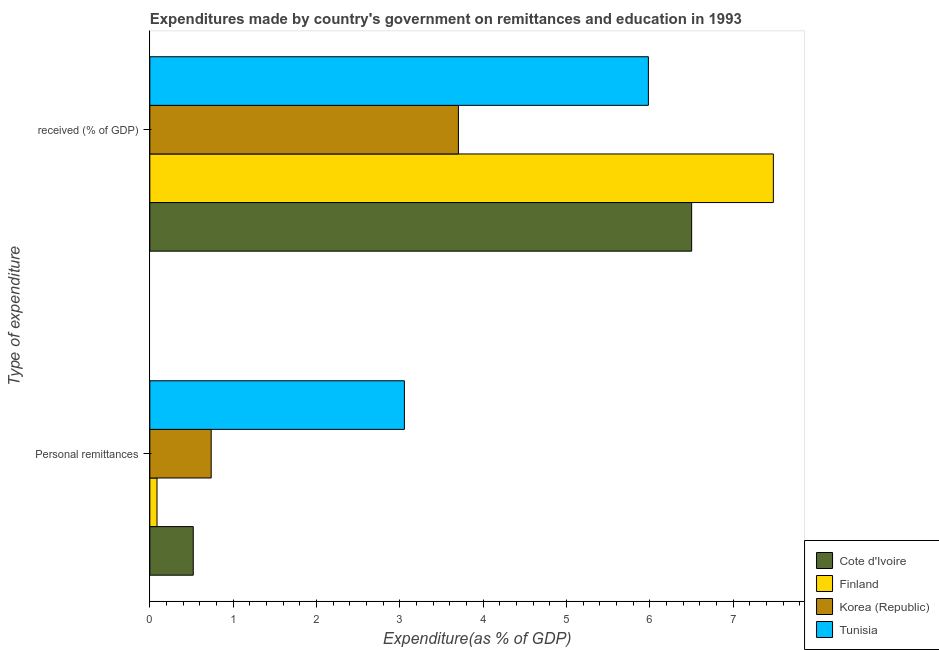How many different coloured bars are there?
Offer a terse response. 4. Are the number of bars per tick equal to the number of legend labels?
Ensure brevity in your answer.  Yes. Are the number of bars on each tick of the Y-axis equal?
Offer a very short reply. Yes. What is the label of the 2nd group of bars from the top?
Offer a terse response. Personal remittances. What is the expenditure in personal remittances in Tunisia?
Your answer should be compact. 3.06. Across all countries, what is the maximum expenditure in education?
Offer a terse response. 7.48. Across all countries, what is the minimum expenditure in personal remittances?
Ensure brevity in your answer.  0.09. What is the total expenditure in personal remittances in the graph?
Ensure brevity in your answer.  4.4. What is the difference between the expenditure in personal remittances in Korea (Republic) and that in Tunisia?
Offer a terse response. -2.32. What is the difference between the expenditure in personal remittances in Korea (Republic) and the expenditure in education in Finland?
Your answer should be very brief. -6.75. What is the average expenditure in personal remittances per country?
Your answer should be compact. 1.1. What is the difference between the expenditure in personal remittances and expenditure in education in Korea (Republic)?
Make the answer very short. -2.97. What is the ratio of the expenditure in education in Tunisia to that in Korea (Republic)?
Ensure brevity in your answer.  1.62. What does the 1st bar from the top in  received (% of GDP) represents?
Your response must be concise. Tunisia. What does the 3rd bar from the bottom in  received (% of GDP) represents?
Provide a short and direct response. Korea (Republic). How many bars are there?
Your answer should be very brief. 8. Are all the bars in the graph horizontal?
Offer a very short reply. Yes. How many countries are there in the graph?
Your response must be concise. 4. Are the values on the major ticks of X-axis written in scientific E-notation?
Ensure brevity in your answer.  No. Does the graph contain grids?
Offer a very short reply. No. What is the title of the graph?
Give a very brief answer. Expenditures made by country's government on remittances and education in 1993. What is the label or title of the X-axis?
Offer a terse response. Expenditure(as % of GDP). What is the label or title of the Y-axis?
Make the answer very short. Type of expenditure. What is the Expenditure(as % of GDP) in Cote d'Ivoire in Personal remittances?
Your answer should be compact. 0.52. What is the Expenditure(as % of GDP) of Finland in Personal remittances?
Your answer should be compact. 0.09. What is the Expenditure(as % of GDP) of Korea (Republic) in Personal remittances?
Give a very brief answer. 0.74. What is the Expenditure(as % of GDP) of Tunisia in Personal remittances?
Ensure brevity in your answer.  3.06. What is the Expenditure(as % of GDP) of Cote d'Ivoire in  received (% of GDP)?
Ensure brevity in your answer.  6.5. What is the Expenditure(as % of GDP) of Finland in  received (% of GDP)?
Keep it short and to the point. 7.48. What is the Expenditure(as % of GDP) of Korea (Republic) in  received (% of GDP)?
Offer a terse response. 3.7. What is the Expenditure(as % of GDP) of Tunisia in  received (% of GDP)?
Offer a terse response. 5.98. Across all Type of expenditure, what is the maximum Expenditure(as % of GDP) in Cote d'Ivoire?
Your answer should be very brief. 6.5. Across all Type of expenditure, what is the maximum Expenditure(as % of GDP) of Finland?
Your answer should be compact. 7.48. Across all Type of expenditure, what is the maximum Expenditure(as % of GDP) in Korea (Republic)?
Your answer should be compact. 3.7. Across all Type of expenditure, what is the maximum Expenditure(as % of GDP) in Tunisia?
Ensure brevity in your answer.  5.98. Across all Type of expenditure, what is the minimum Expenditure(as % of GDP) in Cote d'Ivoire?
Your answer should be very brief. 0.52. Across all Type of expenditure, what is the minimum Expenditure(as % of GDP) of Finland?
Give a very brief answer. 0.09. Across all Type of expenditure, what is the minimum Expenditure(as % of GDP) of Korea (Republic)?
Your answer should be compact. 0.74. Across all Type of expenditure, what is the minimum Expenditure(as % of GDP) in Tunisia?
Ensure brevity in your answer.  3.06. What is the total Expenditure(as % of GDP) in Cote d'Ivoire in the graph?
Offer a terse response. 7.02. What is the total Expenditure(as % of GDP) in Finland in the graph?
Your answer should be compact. 7.57. What is the total Expenditure(as % of GDP) of Korea (Republic) in the graph?
Keep it short and to the point. 4.44. What is the total Expenditure(as % of GDP) in Tunisia in the graph?
Give a very brief answer. 9.04. What is the difference between the Expenditure(as % of GDP) of Cote d'Ivoire in Personal remittances and that in  received (% of GDP)?
Provide a short and direct response. -5.98. What is the difference between the Expenditure(as % of GDP) of Finland in Personal remittances and that in  received (% of GDP)?
Provide a short and direct response. -7.4. What is the difference between the Expenditure(as % of GDP) of Korea (Republic) in Personal remittances and that in  received (% of GDP)?
Your response must be concise. -2.97. What is the difference between the Expenditure(as % of GDP) of Tunisia in Personal remittances and that in  received (% of GDP)?
Provide a succinct answer. -2.93. What is the difference between the Expenditure(as % of GDP) in Cote d'Ivoire in Personal remittances and the Expenditure(as % of GDP) in Finland in  received (% of GDP)?
Provide a succinct answer. -6.96. What is the difference between the Expenditure(as % of GDP) of Cote d'Ivoire in Personal remittances and the Expenditure(as % of GDP) of Korea (Republic) in  received (% of GDP)?
Give a very brief answer. -3.18. What is the difference between the Expenditure(as % of GDP) in Cote d'Ivoire in Personal remittances and the Expenditure(as % of GDP) in Tunisia in  received (% of GDP)?
Keep it short and to the point. -5.46. What is the difference between the Expenditure(as % of GDP) in Finland in Personal remittances and the Expenditure(as % of GDP) in Korea (Republic) in  received (% of GDP)?
Your response must be concise. -3.62. What is the difference between the Expenditure(as % of GDP) of Finland in Personal remittances and the Expenditure(as % of GDP) of Tunisia in  received (% of GDP)?
Provide a short and direct response. -5.9. What is the difference between the Expenditure(as % of GDP) in Korea (Republic) in Personal remittances and the Expenditure(as % of GDP) in Tunisia in  received (% of GDP)?
Your answer should be very brief. -5.25. What is the average Expenditure(as % of GDP) of Cote d'Ivoire per Type of expenditure?
Provide a short and direct response. 3.51. What is the average Expenditure(as % of GDP) of Finland per Type of expenditure?
Your response must be concise. 3.79. What is the average Expenditure(as % of GDP) of Korea (Republic) per Type of expenditure?
Your answer should be compact. 2.22. What is the average Expenditure(as % of GDP) in Tunisia per Type of expenditure?
Provide a short and direct response. 4.52. What is the difference between the Expenditure(as % of GDP) of Cote d'Ivoire and Expenditure(as % of GDP) of Finland in Personal remittances?
Your answer should be very brief. 0.43. What is the difference between the Expenditure(as % of GDP) of Cote d'Ivoire and Expenditure(as % of GDP) of Korea (Republic) in Personal remittances?
Your answer should be compact. -0.22. What is the difference between the Expenditure(as % of GDP) of Cote d'Ivoire and Expenditure(as % of GDP) of Tunisia in Personal remittances?
Offer a terse response. -2.53. What is the difference between the Expenditure(as % of GDP) of Finland and Expenditure(as % of GDP) of Korea (Republic) in Personal remittances?
Your answer should be very brief. -0.65. What is the difference between the Expenditure(as % of GDP) of Finland and Expenditure(as % of GDP) of Tunisia in Personal remittances?
Your response must be concise. -2.97. What is the difference between the Expenditure(as % of GDP) of Korea (Republic) and Expenditure(as % of GDP) of Tunisia in Personal remittances?
Offer a terse response. -2.32. What is the difference between the Expenditure(as % of GDP) of Cote d'Ivoire and Expenditure(as % of GDP) of Finland in  received (% of GDP)?
Offer a very short reply. -0.98. What is the difference between the Expenditure(as % of GDP) of Cote d'Ivoire and Expenditure(as % of GDP) of Korea (Republic) in  received (% of GDP)?
Offer a very short reply. 2.8. What is the difference between the Expenditure(as % of GDP) of Cote d'Ivoire and Expenditure(as % of GDP) of Tunisia in  received (% of GDP)?
Keep it short and to the point. 0.52. What is the difference between the Expenditure(as % of GDP) in Finland and Expenditure(as % of GDP) in Korea (Republic) in  received (% of GDP)?
Provide a short and direct response. 3.78. What is the difference between the Expenditure(as % of GDP) of Finland and Expenditure(as % of GDP) of Tunisia in  received (% of GDP)?
Your response must be concise. 1.5. What is the difference between the Expenditure(as % of GDP) in Korea (Republic) and Expenditure(as % of GDP) in Tunisia in  received (% of GDP)?
Your answer should be compact. -2.28. What is the ratio of the Expenditure(as % of GDP) of Cote d'Ivoire in Personal remittances to that in  received (% of GDP)?
Give a very brief answer. 0.08. What is the ratio of the Expenditure(as % of GDP) of Finland in Personal remittances to that in  received (% of GDP)?
Your response must be concise. 0.01. What is the ratio of the Expenditure(as % of GDP) in Korea (Republic) in Personal remittances to that in  received (% of GDP)?
Keep it short and to the point. 0.2. What is the ratio of the Expenditure(as % of GDP) in Tunisia in Personal remittances to that in  received (% of GDP)?
Provide a short and direct response. 0.51. What is the difference between the highest and the second highest Expenditure(as % of GDP) of Cote d'Ivoire?
Offer a very short reply. 5.98. What is the difference between the highest and the second highest Expenditure(as % of GDP) of Finland?
Keep it short and to the point. 7.4. What is the difference between the highest and the second highest Expenditure(as % of GDP) of Korea (Republic)?
Your response must be concise. 2.97. What is the difference between the highest and the second highest Expenditure(as % of GDP) in Tunisia?
Keep it short and to the point. 2.93. What is the difference between the highest and the lowest Expenditure(as % of GDP) of Cote d'Ivoire?
Offer a very short reply. 5.98. What is the difference between the highest and the lowest Expenditure(as % of GDP) of Finland?
Keep it short and to the point. 7.4. What is the difference between the highest and the lowest Expenditure(as % of GDP) in Korea (Republic)?
Make the answer very short. 2.97. What is the difference between the highest and the lowest Expenditure(as % of GDP) of Tunisia?
Ensure brevity in your answer.  2.93. 